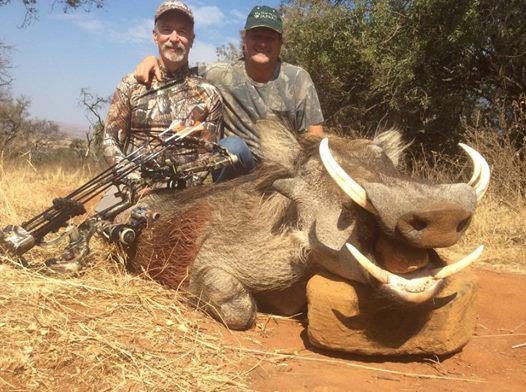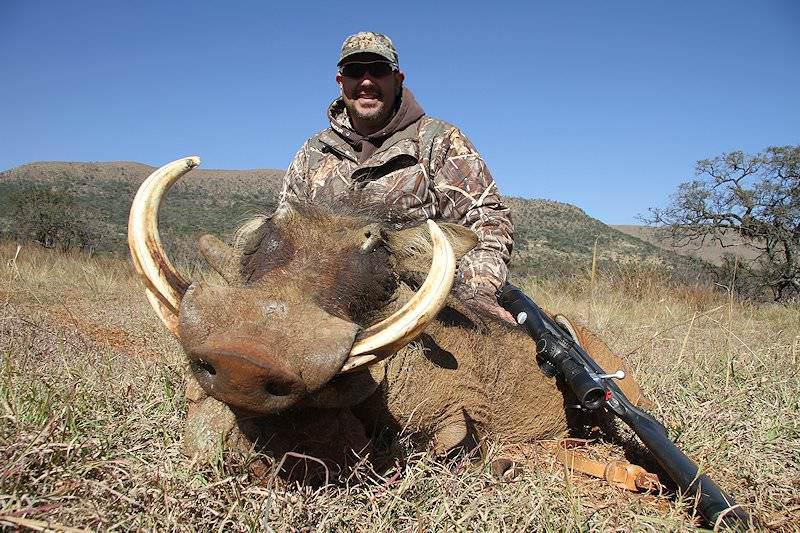The first image is the image on the left, the second image is the image on the right. For the images shown, is this caption "A hunter is posing near the wild pig in the image on the right." true? Answer yes or no. Yes. The first image is the image on the left, the second image is the image on the right. Examine the images to the left and right. Is the description "An image shows exactly one person posed behind a killed warthog." accurate? Answer yes or no. Yes. 